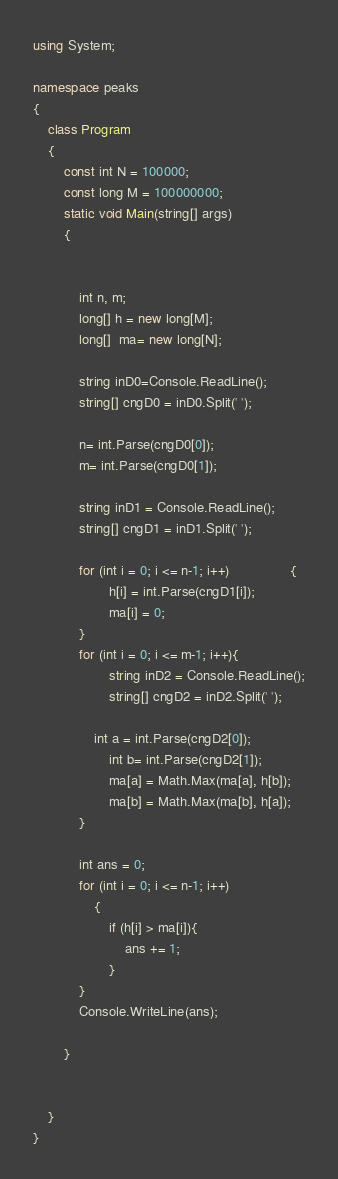<code> <loc_0><loc_0><loc_500><loc_500><_C#_>using System;

namespace peaks
{
    class Program
    {
        const int N = 100000;
        const long M = 100000000;
        static void Main(string[] args)
        {


            int n, m;
            long[] h = new long[M];
            long[]  ma= new long[N];

            string inD0=Console.ReadLine();
            string[] cngD0 = inD0.Split(' ');

            n= int.Parse(cngD0[0]);
            m= int.Parse(cngD0[1]);

            string inD1 = Console.ReadLine();
            string[] cngD1 = inD1.Split(' ');

            for (int i = 0; i <= n-1; i++)                {
                    h[i] = int.Parse(cngD1[i]);
                    ma[i] = 0;
            }
            for (int i = 0; i <= m-1; i++){
                    string inD2 = Console.ReadLine();
                    string[] cngD2 = inD2.Split(' ');

                int a = int.Parse(cngD2[0]);
                    int b= int.Parse(cngD2[1]); 
                    ma[a] = Math.Max(ma[a], h[b]);
                    ma[b] = Math.Max(ma[b], h[a]);
            }
            
            int ans = 0;
            for (int i = 0; i <= n-1; i++)
                {
                    if (h[i] > ma[i]){
                        ans += 1;
                    }
            }
            Console.WriteLine(ans);

        }


    }
}
</code> 